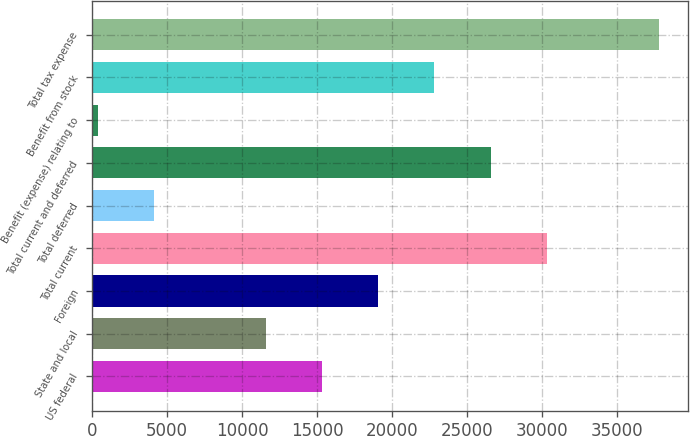Convert chart. <chart><loc_0><loc_0><loc_500><loc_500><bar_chart><fcel>US federal<fcel>State and local<fcel>Foreign<fcel>Total current<fcel>Total deferred<fcel>Total current and deferred<fcel>Benefit (expense) relating to<fcel>Benefit from stock<fcel>Total tax expense<nl><fcel>15345<fcel>11602.5<fcel>19087.5<fcel>30315<fcel>4117.5<fcel>26572.5<fcel>375<fcel>22830<fcel>37800<nl></chart> 